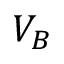<formula> <loc_0><loc_0><loc_500><loc_500>V _ { B }</formula> 